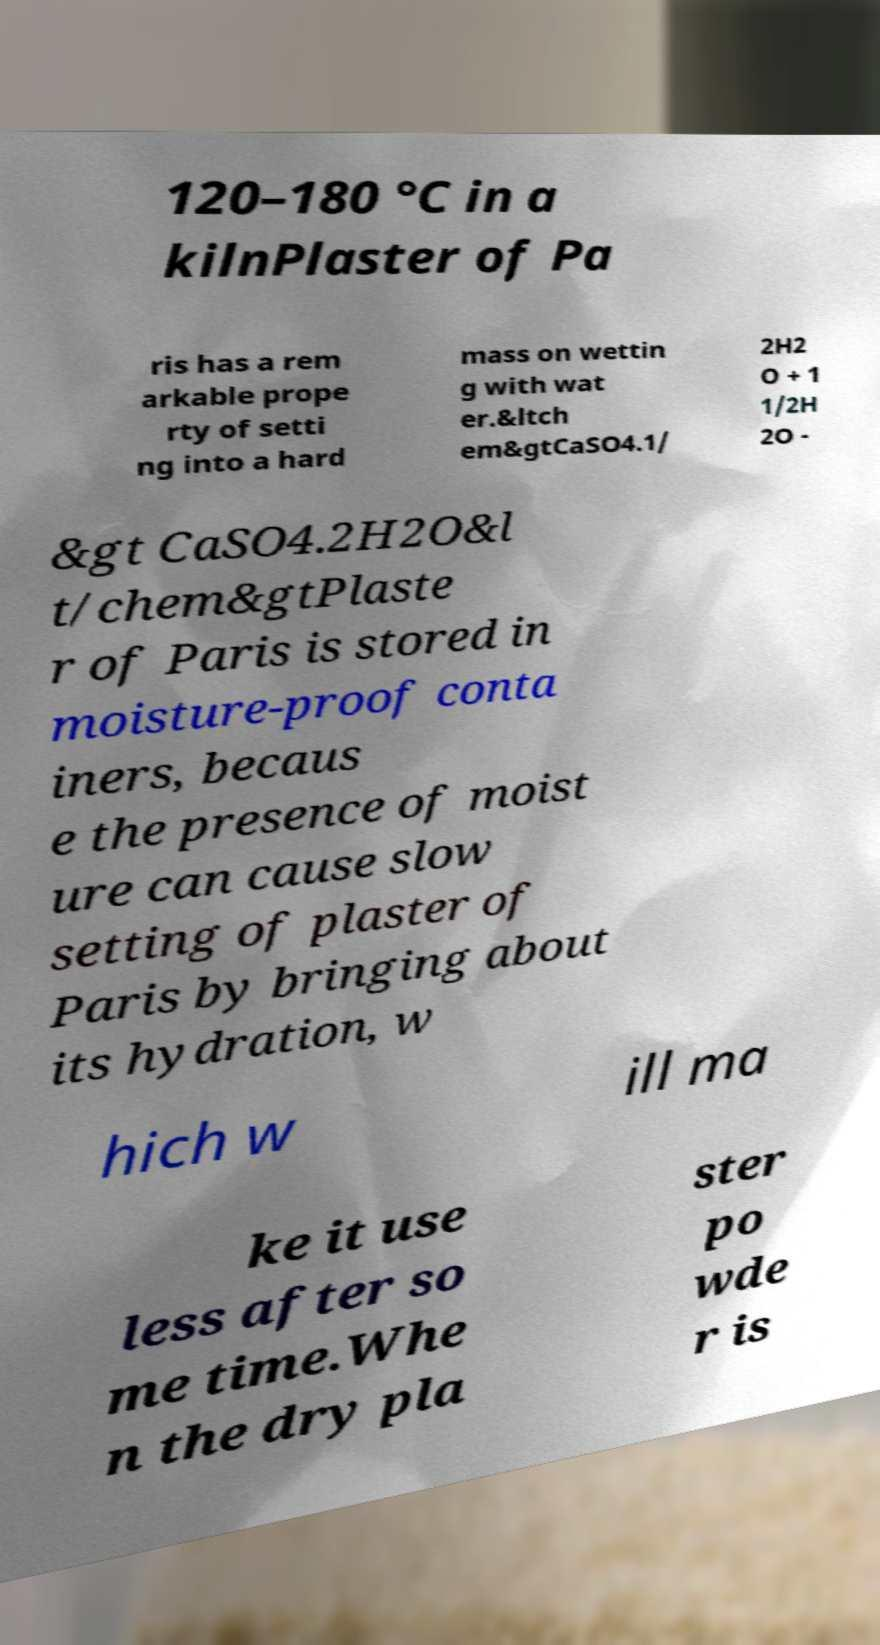Please identify and transcribe the text found in this image. 120–180 °C in a kilnPlaster of Pa ris has a rem arkable prope rty of setti ng into a hard mass on wettin g with wat er.&ltch em&gtCaSO4.1/ 2H2 O + 1 1/2H 2O - &gt CaSO4.2H2O&l t/chem&gtPlaste r of Paris is stored in moisture-proof conta iners, becaus e the presence of moist ure can cause slow setting of plaster of Paris by bringing about its hydration, w hich w ill ma ke it use less after so me time.Whe n the dry pla ster po wde r is 